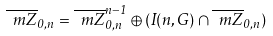<formula> <loc_0><loc_0><loc_500><loc_500>\overline { \ m Z } _ { 0 , n } = \overline { \ m Z } ^ { n - 1 } _ { 0 , n } \oplus ( I ( n , G ) \cap \overline { \ m Z } _ { 0 , n } )</formula> 